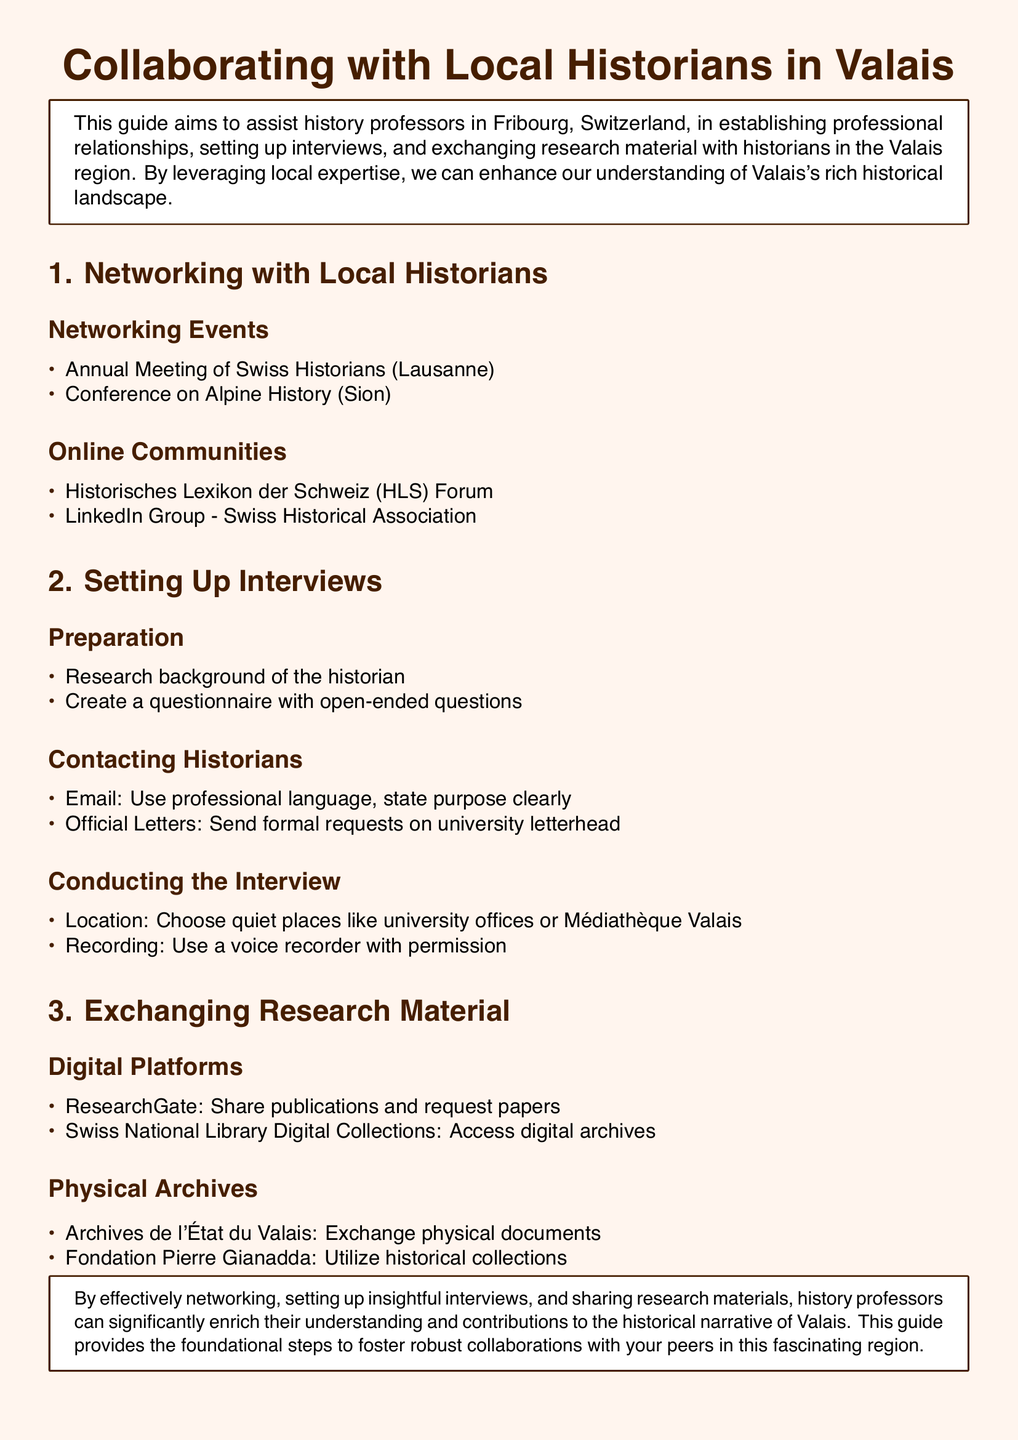what is the title of the guide? The title of the guide, as presented in the document, is "Collaborating with Local Historians in Valais."
Answer: Collaborating with Local Historians in Valais how many networking events are listed? The document lists two networking events under the Networking Events section.
Answer: 2 what online community is mentioned first? The first online community mentioned is the "Historisches Lexikon der Schweiz (HLS) Forum."
Answer: Historisches Lexikon der Schweiz (HLS) Forum what is recommended for conducting interviews? The document suggests choosing quiet places like university offices or Médiathèque Valais for conducting interviews.
Answer: Quiet places like university offices or Médiathèque Valais which digital platform is suggested for sharing publications? ResearchGate is recommended as a digital platform for sharing publications.
Answer: ResearchGate what type of letters should be used when contacting historians? The guide advises using "Official Letters" sent on university letterhead when contacting historians.
Answer: Official Letters how many physical archives are mentioned? The document mentions two physical archives under the Physical Archives section.
Answer: 2 what is the purpose of this guide? The guide aims to assist history professors in establishing professional relationships and enhancing understanding of Valais's historical landscape.
Answer: Assist history professors in establishing professional relationships and enhancing understanding of Valais's historical landscape 